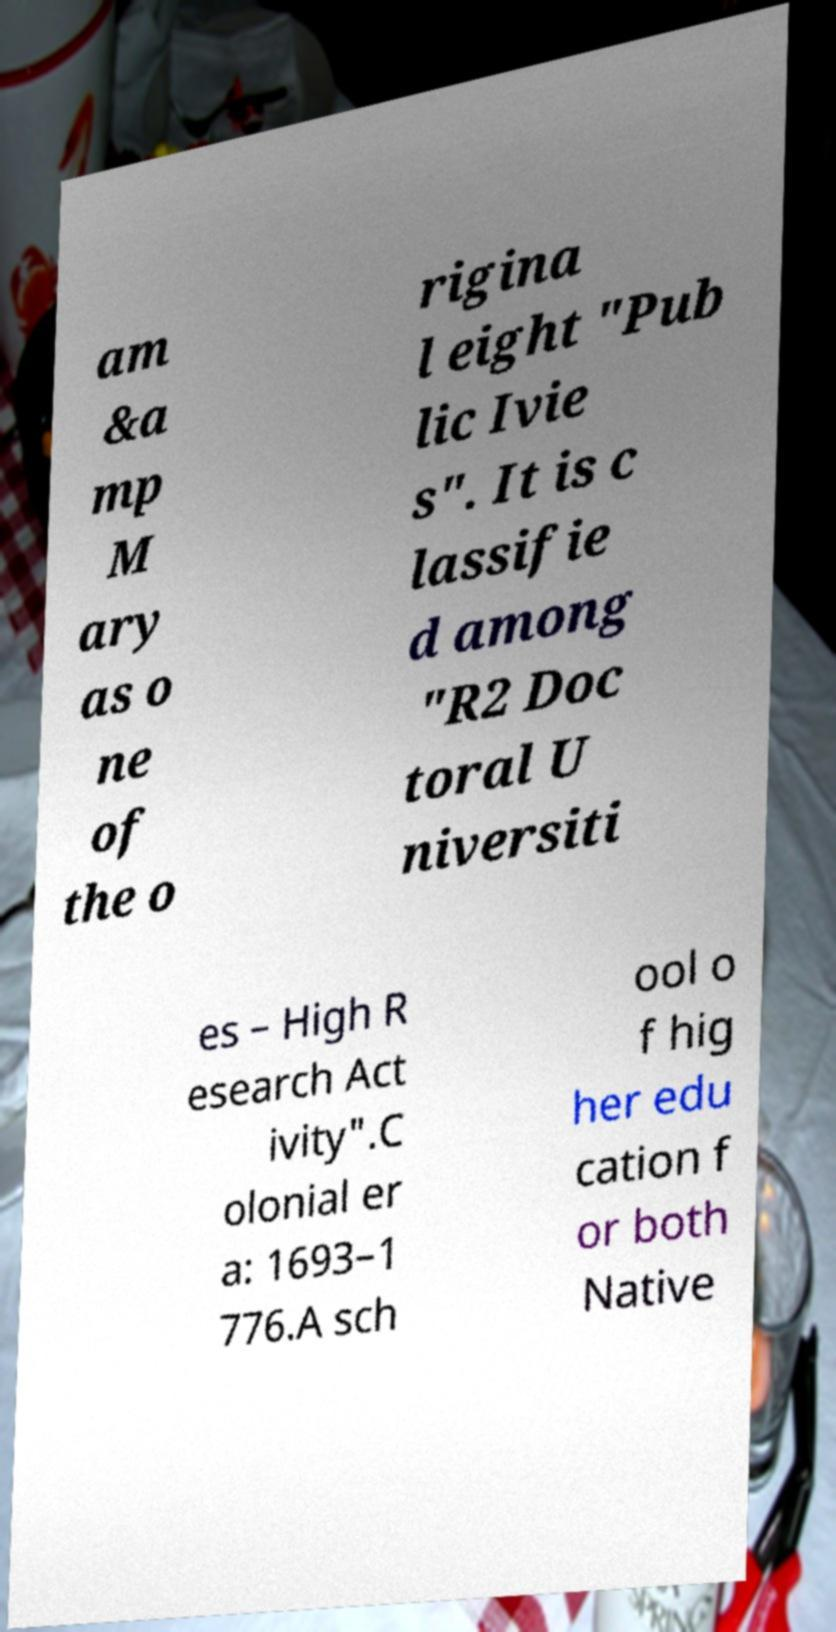Please read and relay the text visible in this image. What does it say? am &a mp M ary as o ne of the o rigina l eight "Pub lic Ivie s". It is c lassifie d among "R2 Doc toral U niversiti es – High R esearch Act ivity".C olonial er a: 1693–1 776.A sch ool o f hig her edu cation f or both Native 